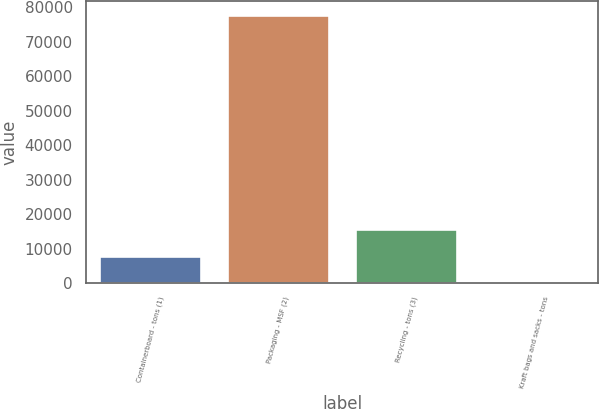Convert chart to OTSL. <chart><loc_0><loc_0><loc_500><loc_500><bar_chart><fcel>Containerboard - tons (1)<fcel>Packaging - MSF (2)<fcel>Recycling - tons (3)<fcel>Kraft bags and sacks - tons<nl><fcel>7866.8<fcel>77822<fcel>15639.6<fcel>94<nl></chart> 